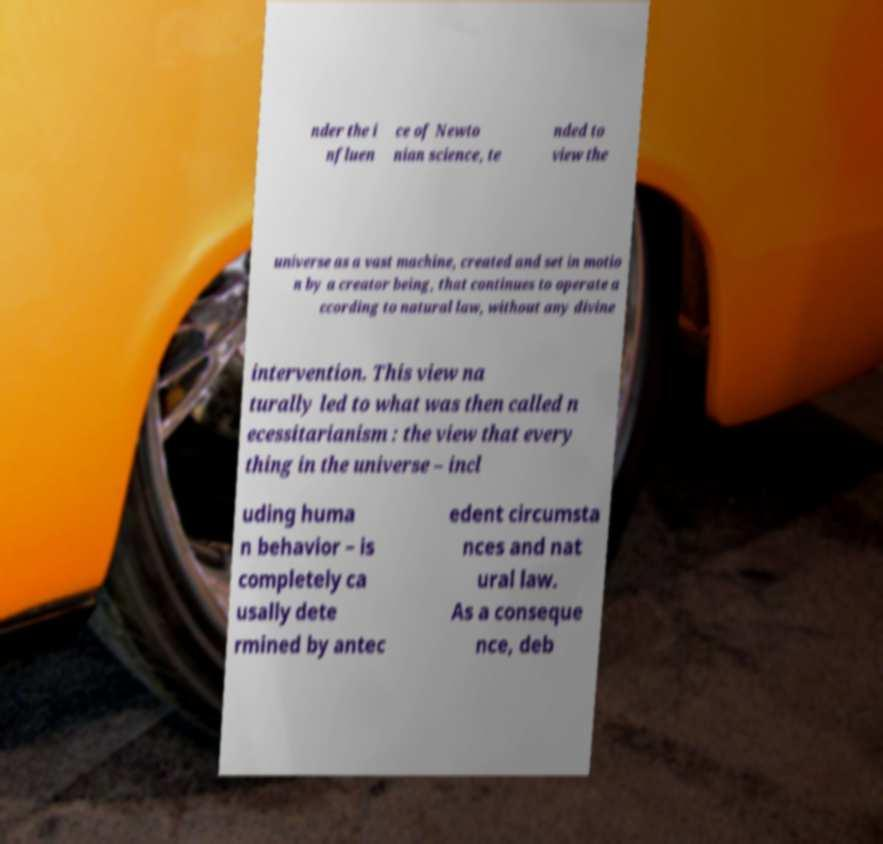What messages or text are displayed in this image? I need them in a readable, typed format. nder the i nfluen ce of Newto nian science, te nded to view the universe as a vast machine, created and set in motio n by a creator being, that continues to operate a ccording to natural law, without any divine intervention. This view na turally led to what was then called n ecessitarianism : the view that every thing in the universe – incl uding huma n behavior – is completely ca usally dete rmined by antec edent circumsta nces and nat ural law. As a conseque nce, deb 